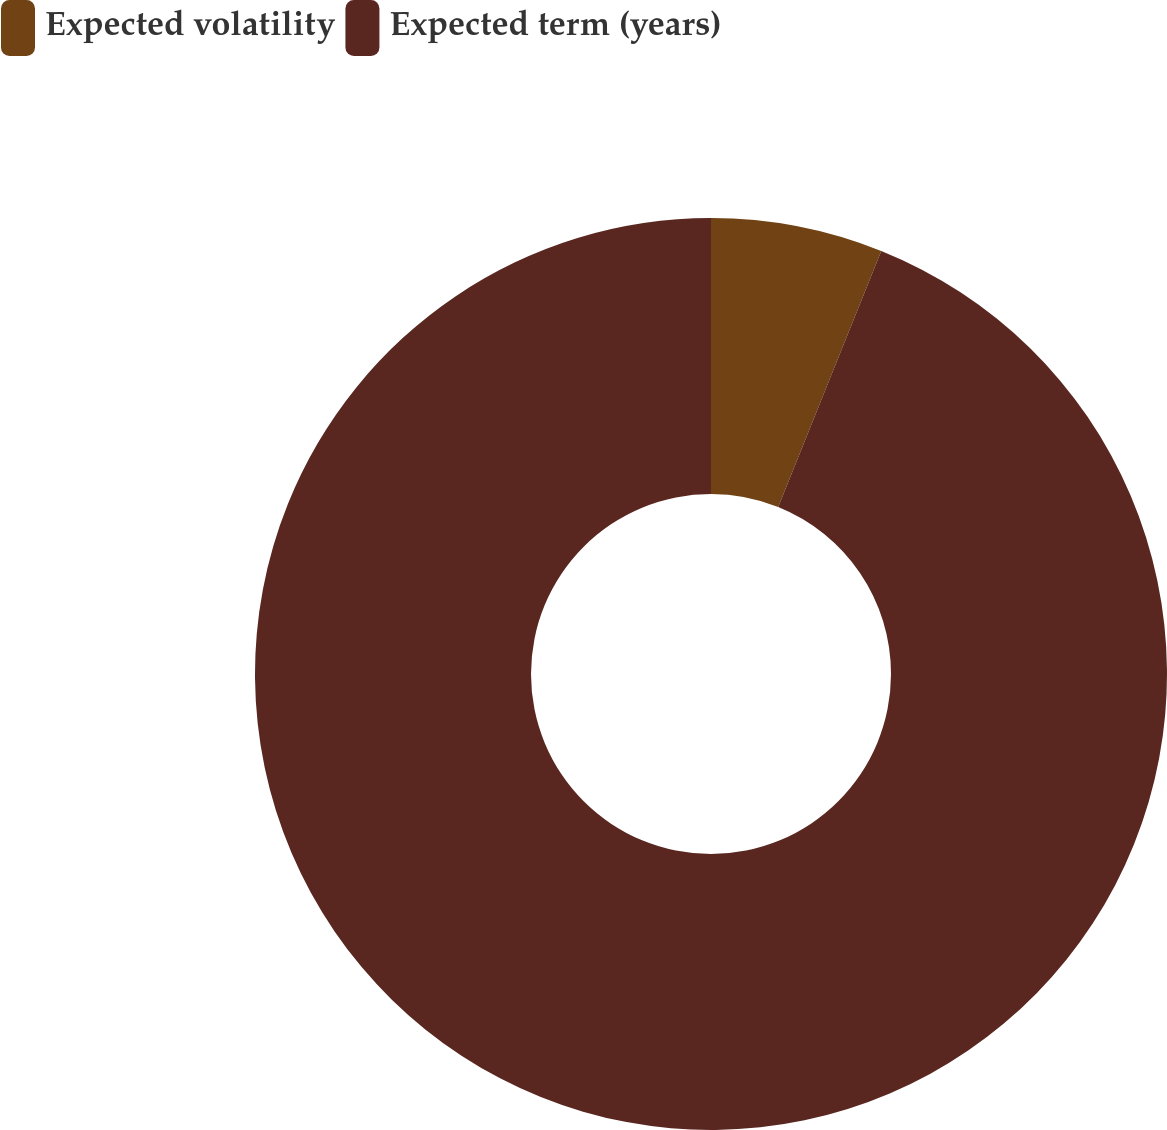<chart> <loc_0><loc_0><loc_500><loc_500><pie_chart><fcel>Expected volatility<fcel>Expected term (years)<nl><fcel>6.09%<fcel>93.91%<nl></chart> 